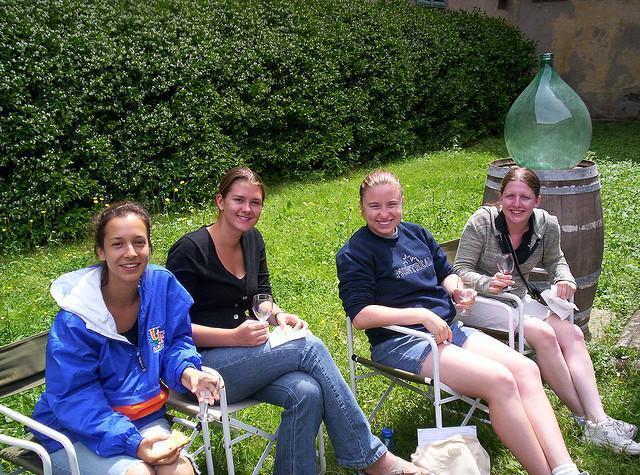How many people in this photo?
Give a very brief answer. 4. How many people can be seen?
Give a very brief answer. 4. How many chairs are there?
Give a very brief answer. 2. 